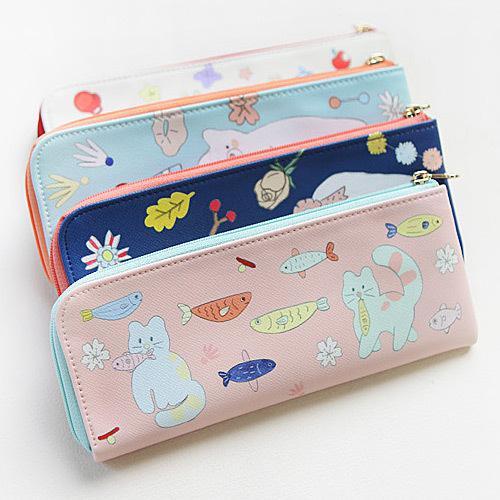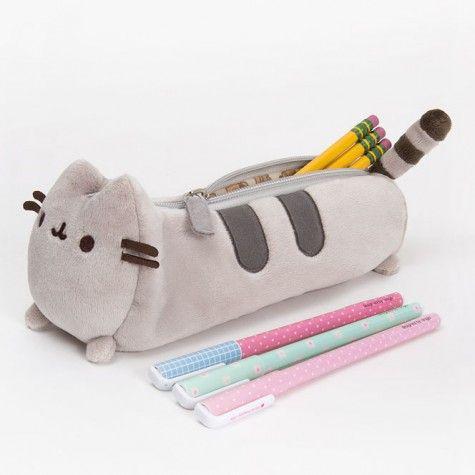The first image is the image on the left, the second image is the image on the right. Examine the images to the left and right. Is the description "One image shows just one pencil case, which has eyes." accurate? Answer yes or no. Yes. The first image is the image on the left, the second image is the image on the right. For the images displayed, is the sentence "One pencil case is unzipped and at least three are closed." factually correct? Answer yes or no. Yes. 